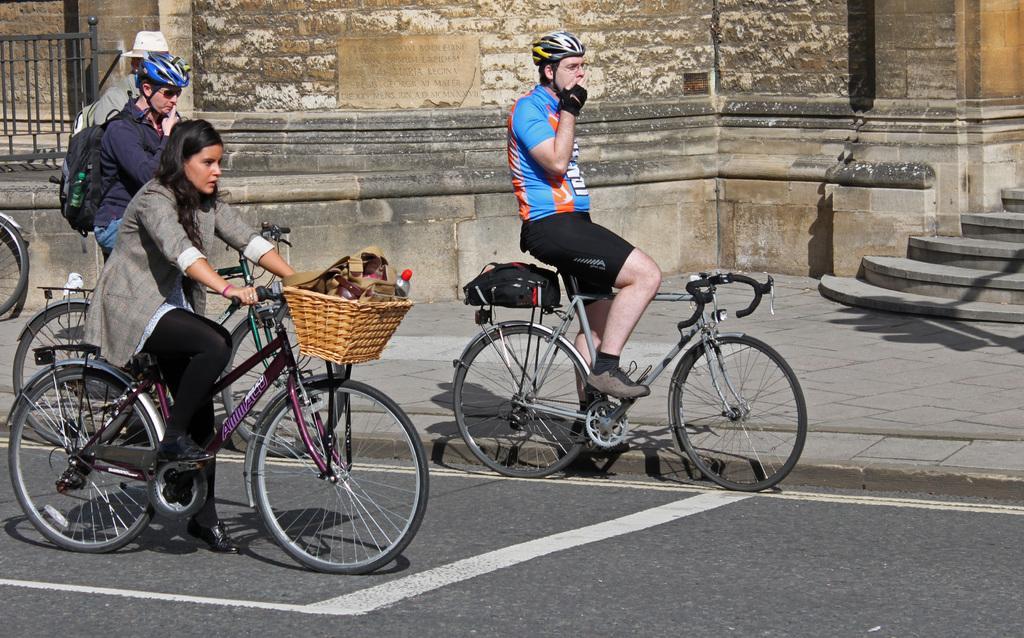Please provide a concise description of this image. These three persons are sitting on the bicycle and holding bicycle,these two persons are wear helmet and this person standing. This is road. On the background we can see wall,steps. 